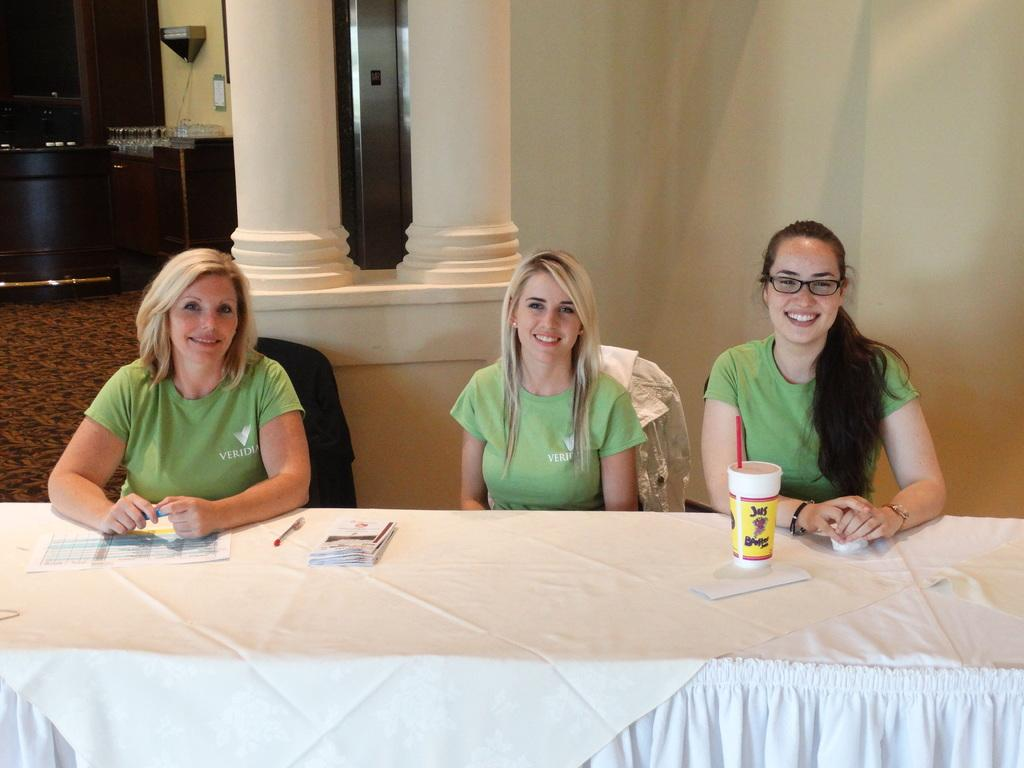What is the color of the wall in the image? The wall in the image is white. How many people are sitting in the image? There are three people sitting in the image. What are the people sitting on? The people are sitting on chairs. What is on the table in front of the chairs? There is a paper, a pen, and a glass on the table. What type of ornament is hanging from the ceiling in the image? There is no ornament hanging from the ceiling in the image. How does the table support the weight of the objects on it? The table supports the weight of the objects on it by providing a stable surface for them to rest on. 